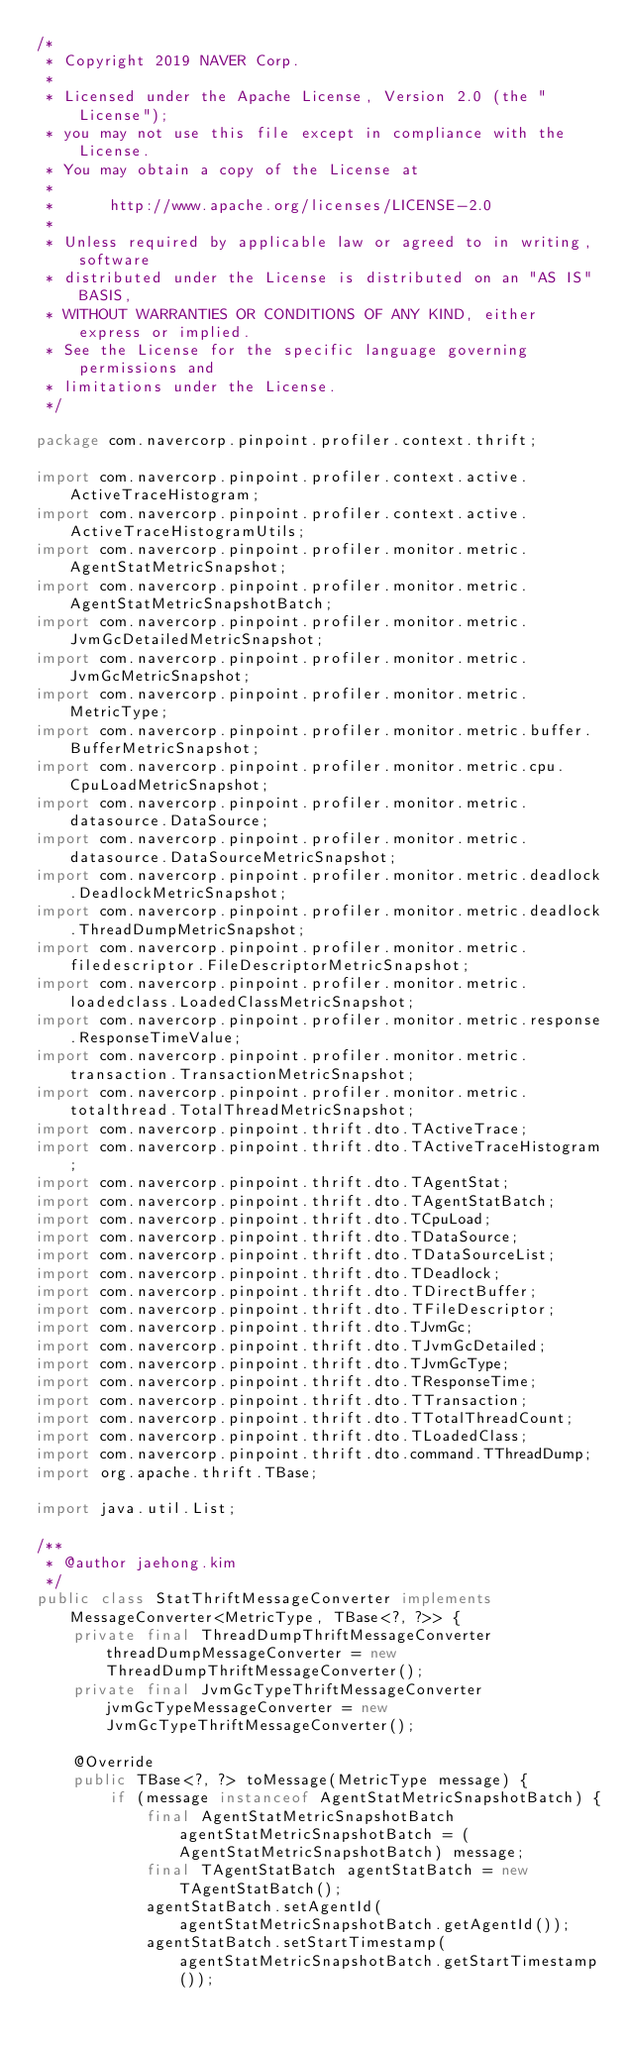<code> <loc_0><loc_0><loc_500><loc_500><_Java_>/*
 * Copyright 2019 NAVER Corp.
 *
 * Licensed under the Apache License, Version 2.0 (the "License");
 * you may not use this file except in compliance with the License.
 * You may obtain a copy of the License at
 *
 *      http://www.apache.org/licenses/LICENSE-2.0
 *
 * Unless required by applicable law or agreed to in writing, software
 * distributed under the License is distributed on an "AS IS" BASIS,
 * WITHOUT WARRANTIES OR CONDITIONS OF ANY KIND, either express or implied.
 * See the License for the specific language governing permissions and
 * limitations under the License.
 */

package com.navercorp.pinpoint.profiler.context.thrift;

import com.navercorp.pinpoint.profiler.context.active.ActiveTraceHistogram;
import com.navercorp.pinpoint.profiler.context.active.ActiveTraceHistogramUtils;
import com.navercorp.pinpoint.profiler.monitor.metric.AgentStatMetricSnapshot;
import com.navercorp.pinpoint.profiler.monitor.metric.AgentStatMetricSnapshotBatch;
import com.navercorp.pinpoint.profiler.monitor.metric.JvmGcDetailedMetricSnapshot;
import com.navercorp.pinpoint.profiler.monitor.metric.JvmGcMetricSnapshot;
import com.navercorp.pinpoint.profiler.monitor.metric.MetricType;
import com.navercorp.pinpoint.profiler.monitor.metric.buffer.BufferMetricSnapshot;
import com.navercorp.pinpoint.profiler.monitor.metric.cpu.CpuLoadMetricSnapshot;
import com.navercorp.pinpoint.profiler.monitor.metric.datasource.DataSource;
import com.navercorp.pinpoint.profiler.monitor.metric.datasource.DataSourceMetricSnapshot;
import com.navercorp.pinpoint.profiler.monitor.metric.deadlock.DeadlockMetricSnapshot;
import com.navercorp.pinpoint.profiler.monitor.metric.deadlock.ThreadDumpMetricSnapshot;
import com.navercorp.pinpoint.profiler.monitor.metric.filedescriptor.FileDescriptorMetricSnapshot;
import com.navercorp.pinpoint.profiler.monitor.metric.loadedclass.LoadedClassMetricSnapshot;
import com.navercorp.pinpoint.profiler.monitor.metric.response.ResponseTimeValue;
import com.navercorp.pinpoint.profiler.monitor.metric.transaction.TransactionMetricSnapshot;
import com.navercorp.pinpoint.profiler.monitor.metric.totalthread.TotalThreadMetricSnapshot;
import com.navercorp.pinpoint.thrift.dto.TActiveTrace;
import com.navercorp.pinpoint.thrift.dto.TActiveTraceHistogram;
import com.navercorp.pinpoint.thrift.dto.TAgentStat;
import com.navercorp.pinpoint.thrift.dto.TAgentStatBatch;
import com.navercorp.pinpoint.thrift.dto.TCpuLoad;
import com.navercorp.pinpoint.thrift.dto.TDataSource;
import com.navercorp.pinpoint.thrift.dto.TDataSourceList;
import com.navercorp.pinpoint.thrift.dto.TDeadlock;
import com.navercorp.pinpoint.thrift.dto.TDirectBuffer;
import com.navercorp.pinpoint.thrift.dto.TFileDescriptor;
import com.navercorp.pinpoint.thrift.dto.TJvmGc;
import com.navercorp.pinpoint.thrift.dto.TJvmGcDetailed;
import com.navercorp.pinpoint.thrift.dto.TJvmGcType;
import com.navercorp.pinpoint.thrift.dto.TResponseTime;
import com.navercorp.pinpoint.thrift.dto.TTransaction;
import com.navercorp.pinpoint.thrift.dto.TTotalThreadCount;
import com.navercorp.pinpoint.thrift.dto.TLoadedClass;
import com.navercorp.pinpoint.thrift.dto.command.TThreadDump;
import org.apache.thrift.TBase;

import java.util.List;

/**
 * @author jaehong.kim
 */
public class StatThriftMessageConverter implements MessageConverter<MetricType, TBase<?, ?>> {
    private final ThreadDumpThriftMessageConverter threadDumpMessageConverter = new ThreadDumpThriftMessageConverter();
    private final JvmGcTypeThriftMessageConverter jvmGcTypeMessageConverter = new JvmGcTypeThriftMessageConverter();

    @Override
    public TBase<?, ?> toMessage(MetricType message) {
        if (message instanceof AgentStatMetricSnapshotBatch) {
            final AgentStatMetricSnapshotBatch agentStatMetricSnapshotBatch = (AgentStatMetricSnapshotBatch) message;
            final TAgentStatBatch agentStatBatch = new TAgentStatBatch();
            agentStatBatch.setAgentId(agentStatMetricSnapshotBatch.getAgentId());
            agentStatBatch.setStartTimestamp(agentStatMetricSnapshotBatch.getStartTimestamp());</code> 